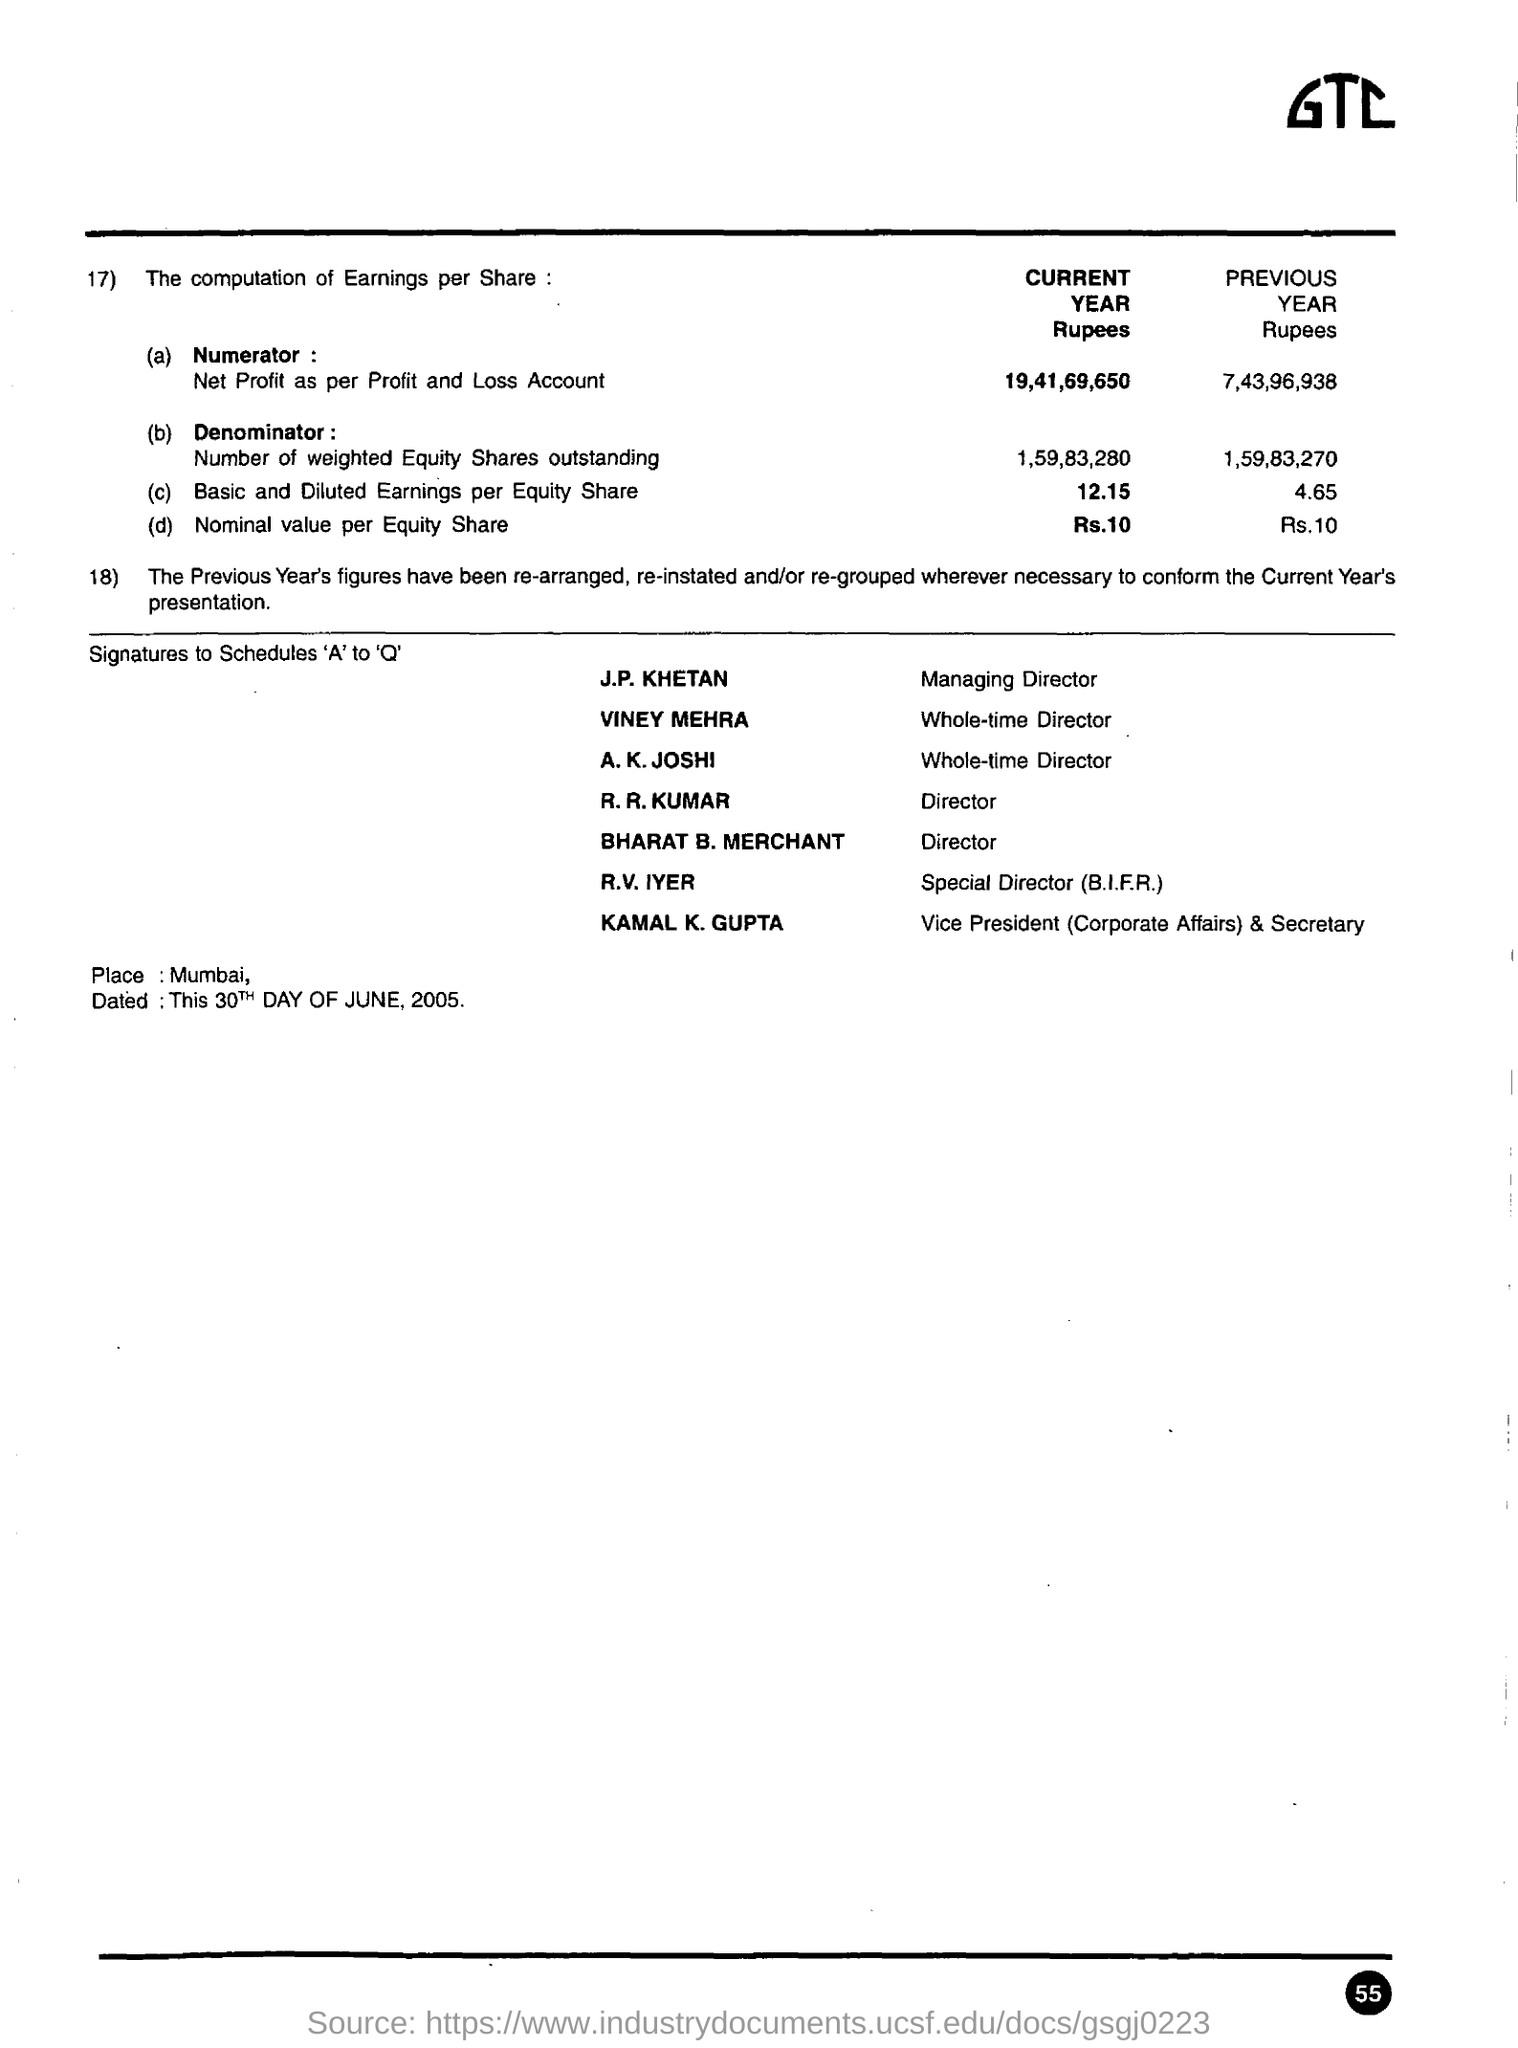Give some essential details in this illustration. The place mentioned is Mumbai. The individual who holds the position of vice president (corporate affairs) and Secretary is Kamal K. Gupta. J.P. Khetan is the managing director. 